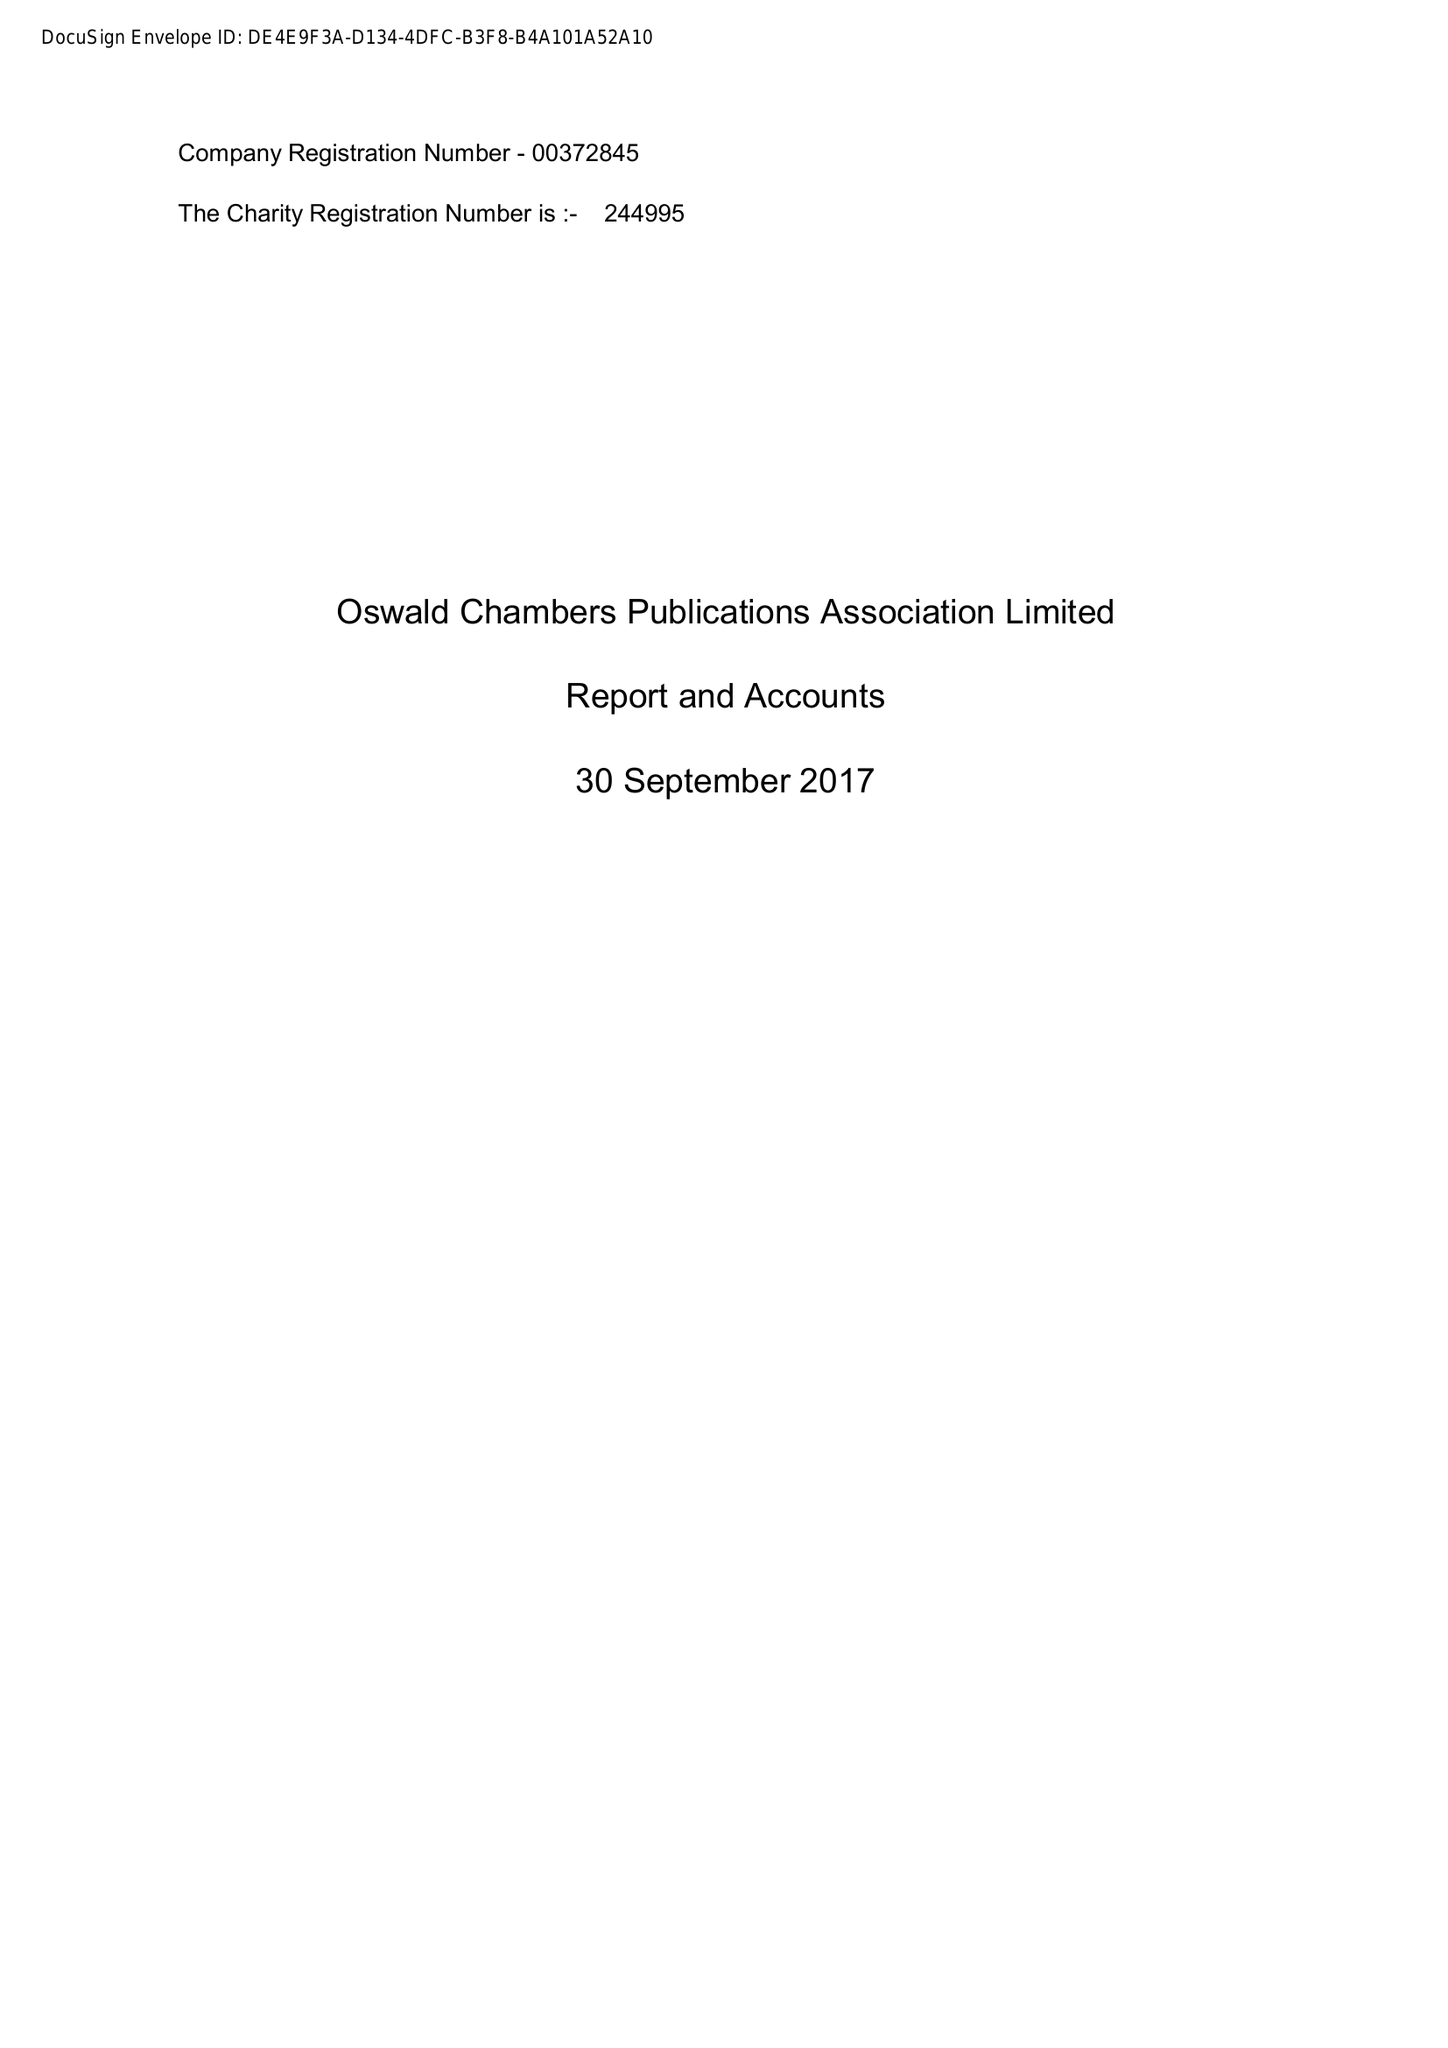What is the value for the address__street_line?
Answer the question using a single word or phrase. HIGHTOWN 